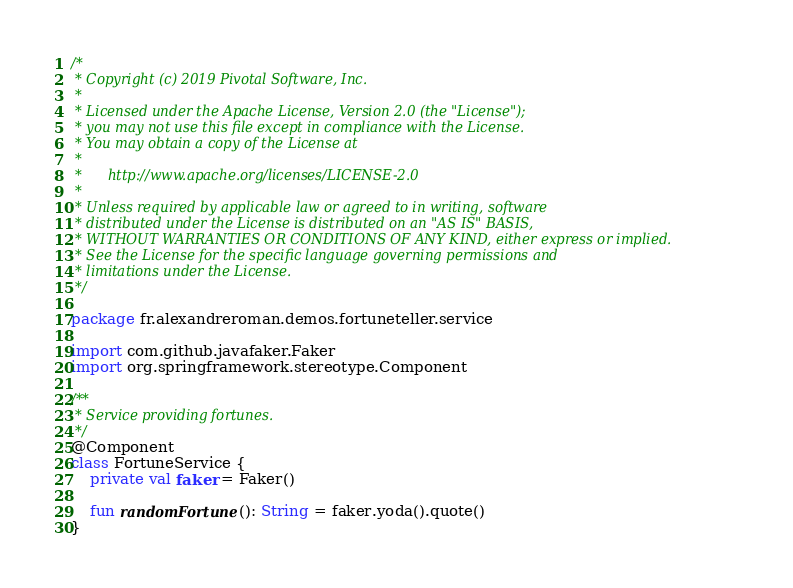Convert code to text. <code><loc_0><loc_0><loc_500><loc_500><_Kotlin_>/*
 * Copyright (c) 2019 Pivotal Software, Inc.
 *
 * Licensed under the Apache License, Version 2.0 (the "License");
 * you may not use this file except in compliance with the License.
 * You may obtain a copy of the License at
 *
 *      http://www.apache.org/licenses/LICENSE-2.0
 *
 * Unless required by applicable law or agreed to in writing, software
 * distributed under the License is distributed on an "AS IS" BASIS,
 * WITHOUT WARRANTIES OR CONDITIONS OF ANY KIND, either express or implied.
 * See the License for the specific language governing permissions and
 * limitations under the License.
 */

package fr.alexandreroman.demos.fortuneteller.service

import com.github.javafaker.Faker
import org.springframework.stereotype.Component

/**
 * Service providing fortunes.
 */
@Component
class FortuneService {
    private val faker = Faker()

    fun randomFortune(): String = faker.yoda().quote()
}
</code> 